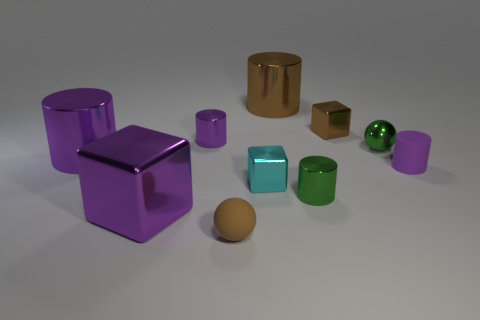Can you describe the shapes and their arrangement on the surface? Certainly! In the image, there are a variety of geometric shapes neatly arranged on a flat surface. Starting from the left, there's a large purple metallic cube, followed by a metallic sphere and a cylindrical object. Scattered across the image are smaller objects, including a golden cube, another small purple cube, a green metallic cube, a translucent cyan cube, and a couple of cylinders. The composition suggests an organized diversity of basic geometric shapes. 